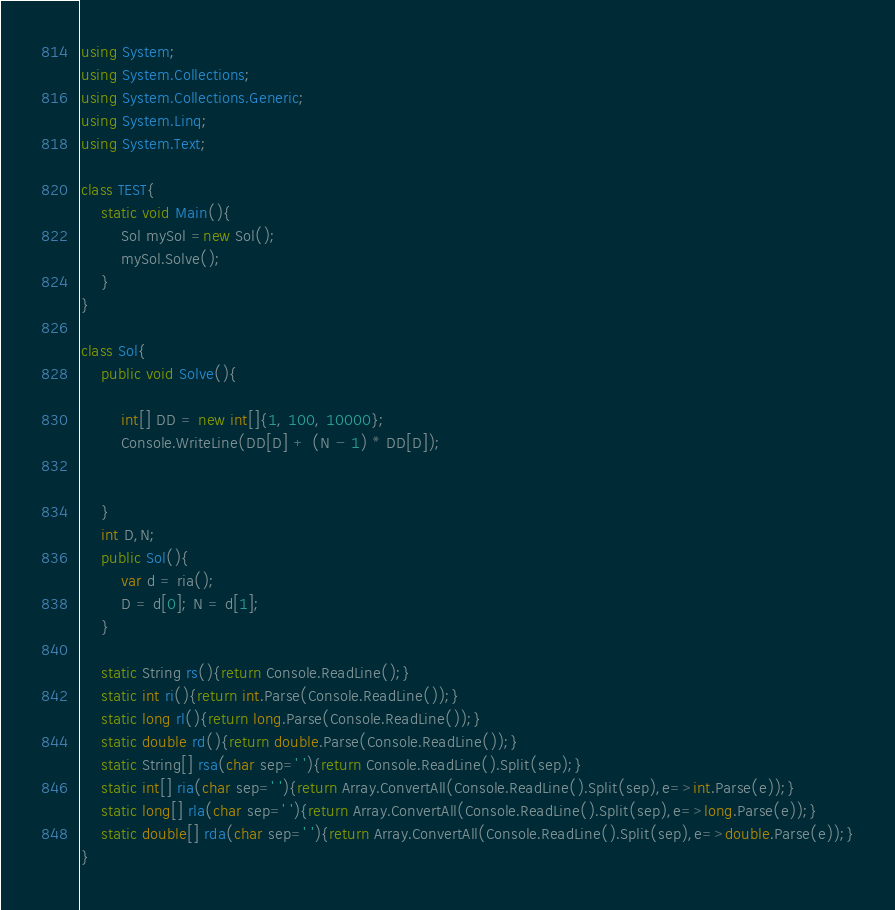Convert code to text. <code><loc_0><loc_0><loc_500><loc_500><_C#_>using System;
using System.Collections;
using System.Collections.Generic;
using System.Linq;
using System.Text;

class TEST{
	static void Main(){
		Sol mySol =new Sol();
		mySol.Solve();
	}
}

class Sol{
	public void Solve(){
		
		int[] DD = new int[]{1, 100, 10000};
		Console.WriteLine(DD[D] + (N - 1) * DD[D]);
		
		
	}
	int D,N;
	public Sol(){
		var d = ria();
		D = d[0]; N = d[1];
	}

	static String rs(){return Console.ReadLine();}
	static int ri(){return int.Parse(Console.ReadLine());}
	static long rl(){return long.Parse(Console.ReadLine());}
	static double rd(){return double.Parse(Console.ReadLine());}
	static String[] rsa(char sep=' '){return Console.ReadLine().Split(sep);}
	static int[] ria(char sep=' '){return Array.ConvertAll(Console.ReadLine().Split(sep),e=>int.Parse(e));}
	static long[] rla(char sep=' '){return Array.ConvertAll(Console.ReadLine().Split(sep),e=>long.Parse(e));}
	static double[] rda(char sep=' '){return Array.ConvertAll(Console.ReadLine().Split(sep),e=>double.Parse(e));}
}
</code> 